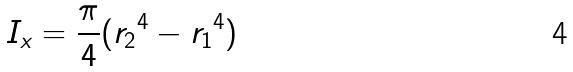Convert formula to latex. <formula><loc_0><loc_0><loc_500><loc_500>I _ { x } = \frac { \pi } { 4 } ( { r _ { 2 } } ^ { 4 } - { r _ { 1 } } ^ { 4 } )</formula> 